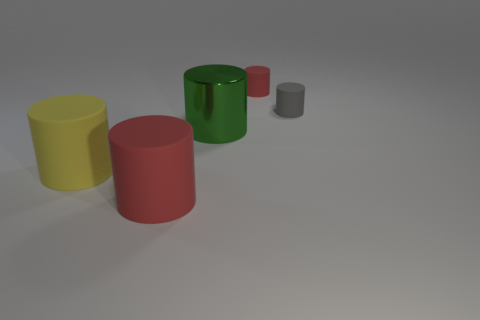Subtract all green cylinders. How many cylinders are left? 4 Subtract all red matte cylinders. How many cylinders are left? 3 Subtract all green blocks. How many red cylinders are left? 2 Subtract all green cylinders. Subtract all blue spheres. How many cylinders are left? 4 Add 4 tiny green matte things. How many objects exist? 9 Add 3 yellow objects. How many yellow objects are left? 4 Add 4 big yellow matte objects. How many big yellow matte objects exist? 5 Subtract 2 red cylinders. How many objects are left? 3 Subtract all small gray objects. Subtract all tiny blue spheres. How many objects are left? 4 